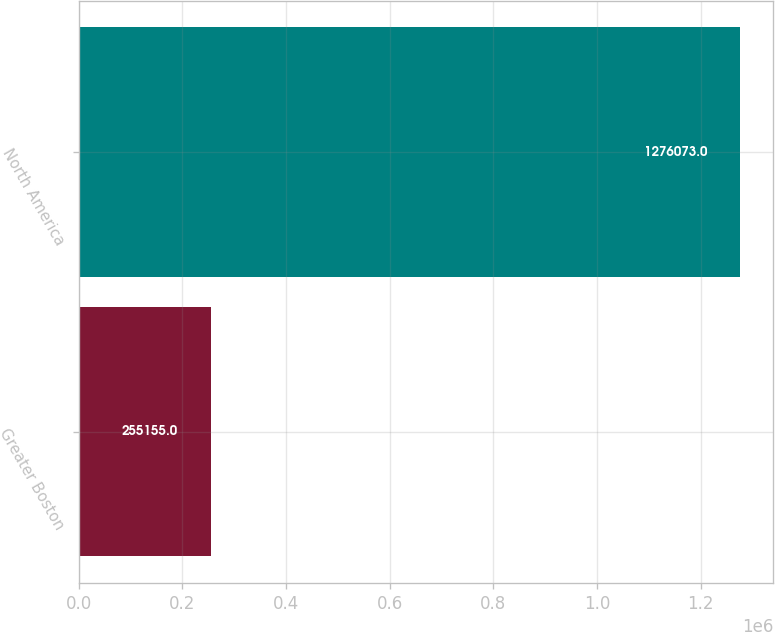<chart> <loc_0><loc_0><loc_500><loc_500><bar_chart><fcel>Greater Boston<fcel>North America<nl><fcel>255155<fcel>1.27607e+06<nl></chart> 